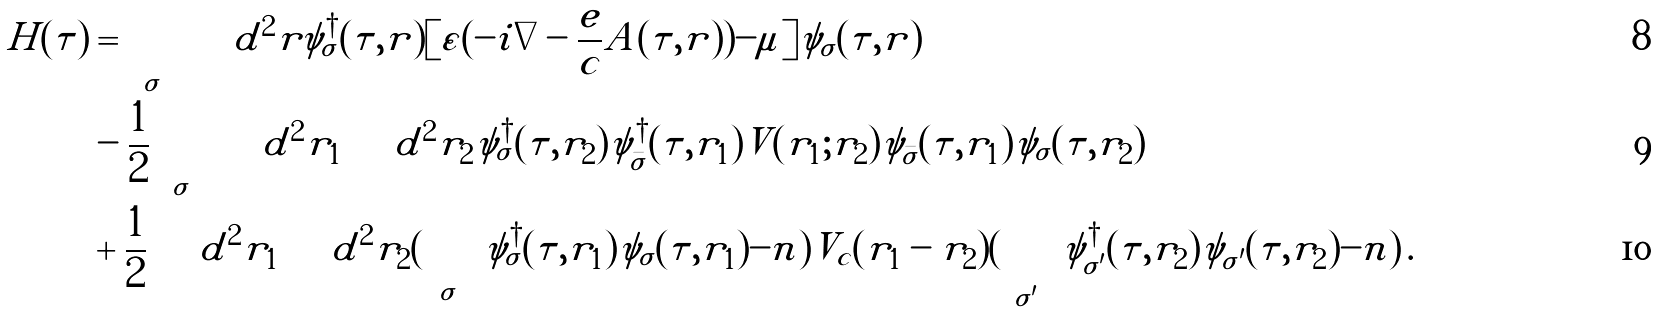<formula> <loc_0><loc_0><loc_500><loc_500>H ( \tau ) & = \sum _ { \sigma } \int d ^ { 2 } r \psi _ { \sigma } ^ { \dagger } ( \tau , { r } ) [ \varepsilon ( - i \nabla - \frac { e } { c } { A } ( \tau , { r } ) ) - \mu ] \psi _ { \sigma } ( \tau , { r } ) \\ & - \frac { 1 } { 2 } \sum _ { \sigma } \int d ^ { 2 } r _ { 1 } \int d ^ { 2 } r _ { 2 } \psi _ { \sigma } ^ { \dagger } ( \tau , { r } _ { 2 } ) \psi _ { \bar { \sigma } } ^ { \dagger } ( \tau , { r } _ { 1 } ) V ( { r } _ { 1 } ; { r } _ { 2 } ) \psi _ { \bar { \sigma } } ( \tau , { r } _ { 1 } ) \psi _ { \sigma } ( \tau , { r } _ { 2 } ) \\ & + \frac { 1 } { 2 } \int d ^ { 2 } r _ { 1 } \int d ^ { 2 } r _ { 2 } ( \sum _ { \sigma } \psi _ { \sigma } ^ { \dagger } ( \tau , { r } _ { 1 } ) \psi _ { \sigma } ( \tau , { r } _ { 1 } ) - n ) V _ { c } ( { r } _ { 1 } - { r } _ { 2 } ) ( \sum _ { \sigma ^ { \prime } } \psi _ { \sigma ^ { \prime } } ^ { \dagger } ( \tau , { r } _ { 2 } ) \psi _ { \sigma ^ { \prime } } ( \tau , { r } _ { 2 } ) - n ) \, .</formula> 